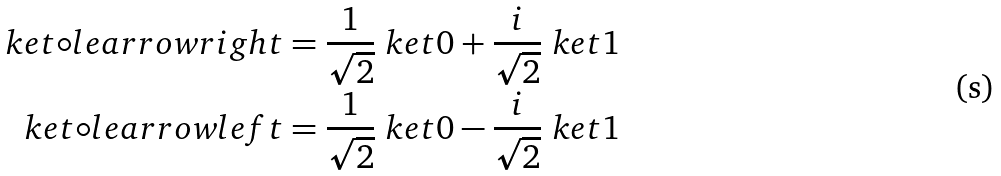<formula> <loc_0><loc_0><loc_500><loc_500>\ k e t { \circ l e a r r o w r i g h t } & = \frac { 1 } { \sqrt { 2 } } \ k e t { 0 } + \frac { i } { \sqrt { 2 } } \ k e t { 1 } \\ \ k e t { \circ l e a r r o w l e f t } & = \frac { 1 } { \sqrt { 2 } } \ k e t { 0 } - \frac { i } { \sqrt { 2 } } \ k e t { 1 }</formula> 